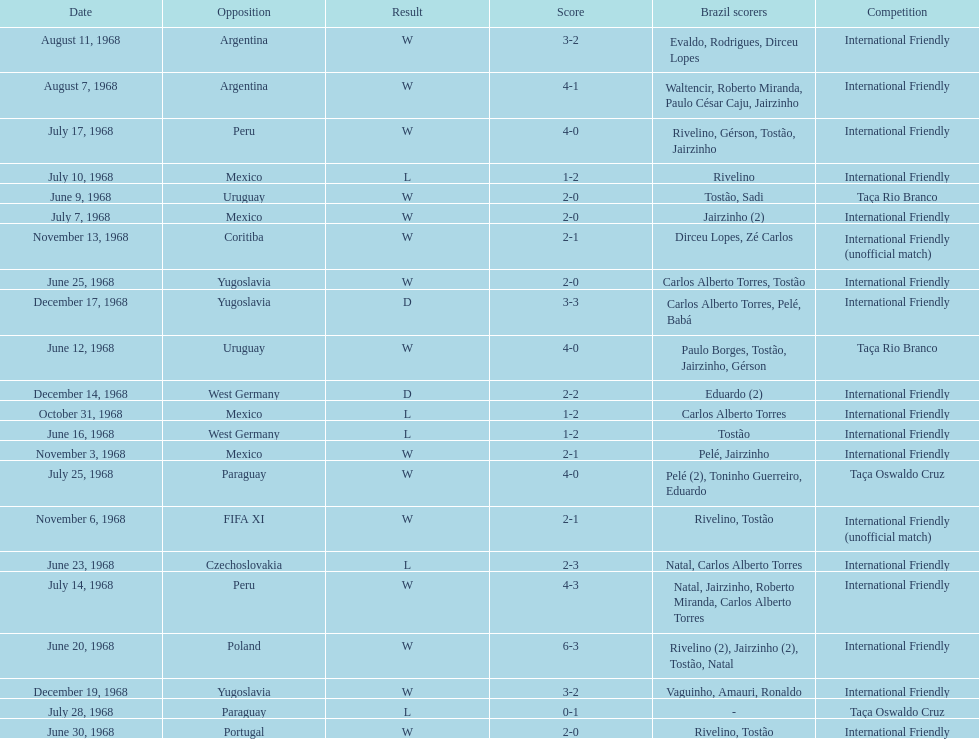Name the first competition ever played by brazil. Taça Rio Branco. 